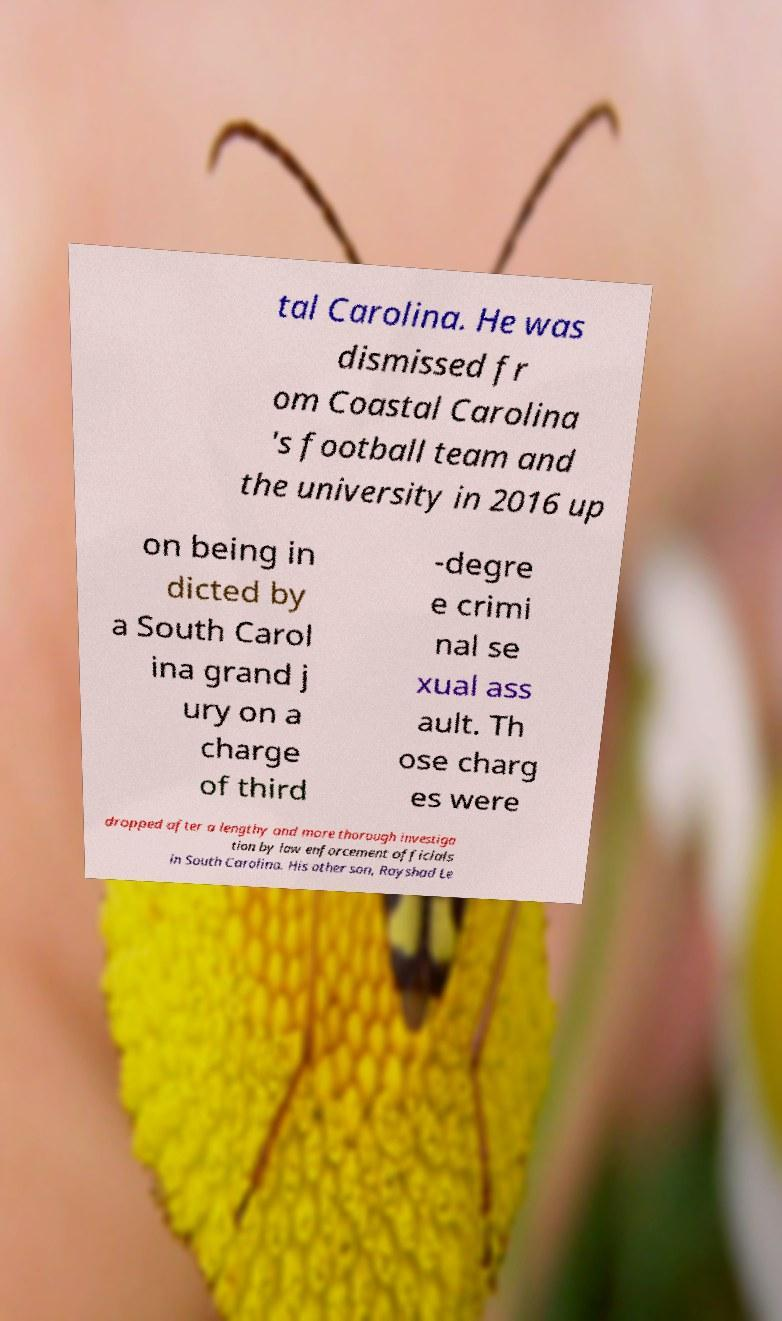Could you extract and type out the text from this image? tal Carolina. He was dismissed fr om Coastal Carolina 's football team and the university in 2016 up on being in dicted by a South Carol ina grand j ury on a charge of third -degre e crimi nal se xual ass ault. Th ose charg es were dropped after a lengthy and more thorough investiga tion by law enforcement officials in South Carolina. His other son, Rayshad Le 